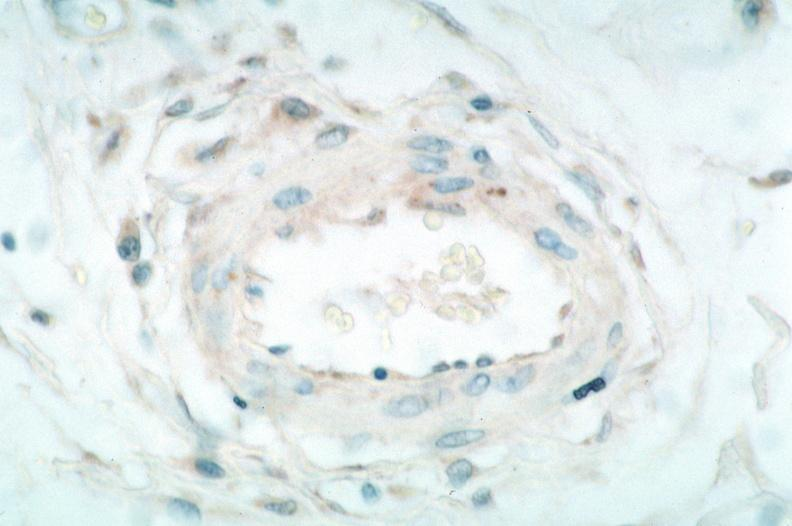what is rocky mountain spotted?
Answer the question using a single word or phrase. Fever 